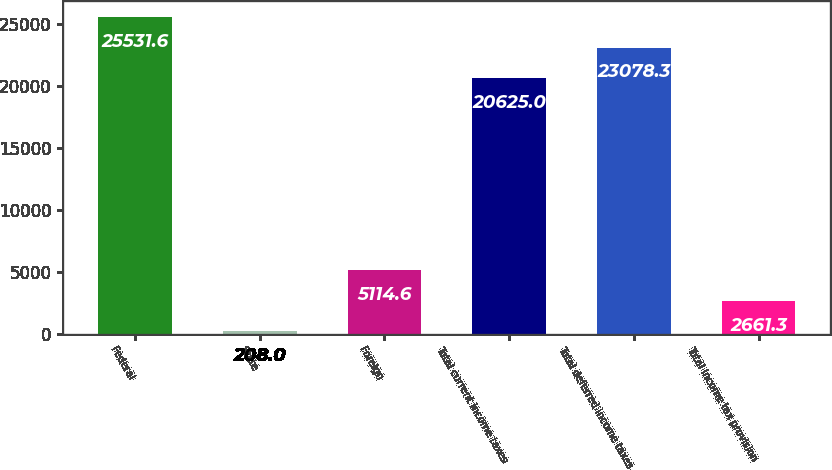Convert chart to OTSL. <chart><loc_0><loc_0><loc_500><loc_500><bar_chart><fcel>Federal<fcel>State<fcel>Foreign<fcel>Total current income taxes<fcel>Total deferred income taxes<fcel>Total income tax provision<nl><fcel>25531.6<fcel>208<fcel>5114.6<fcel>20625<fcel>23078.3<fcel>2661.3<nl></chart> 